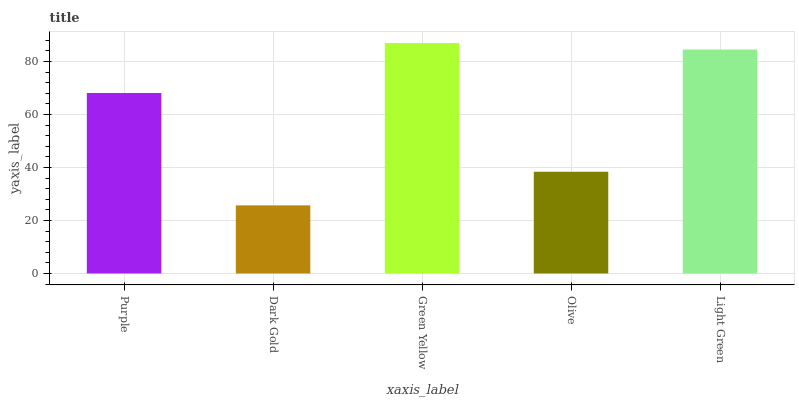Is Green Yellow the minimum?
Answer yes or no. No. Is Dark Gold the maximum?
Answer yes or no. No. Is Green Yellow greater than Dark Gold?
Answer yes or no. Yes. Is Dark Gold less than Green Yellow?
Answer yes or no. Yes. Is Dark Gold greater than Green Yellow?
Answer yes or no. No. Is Green Yellow less than Dark Gold?
Answer yes or no. No. Is Purple the high median?
Answer yes or no. Yes. Is Purple the low median?
Answer yes or no. Yes. Is Green Yellow the high median?
Answer yes or no. No. Is Light Green the low median?
Answer yes or no. No. 